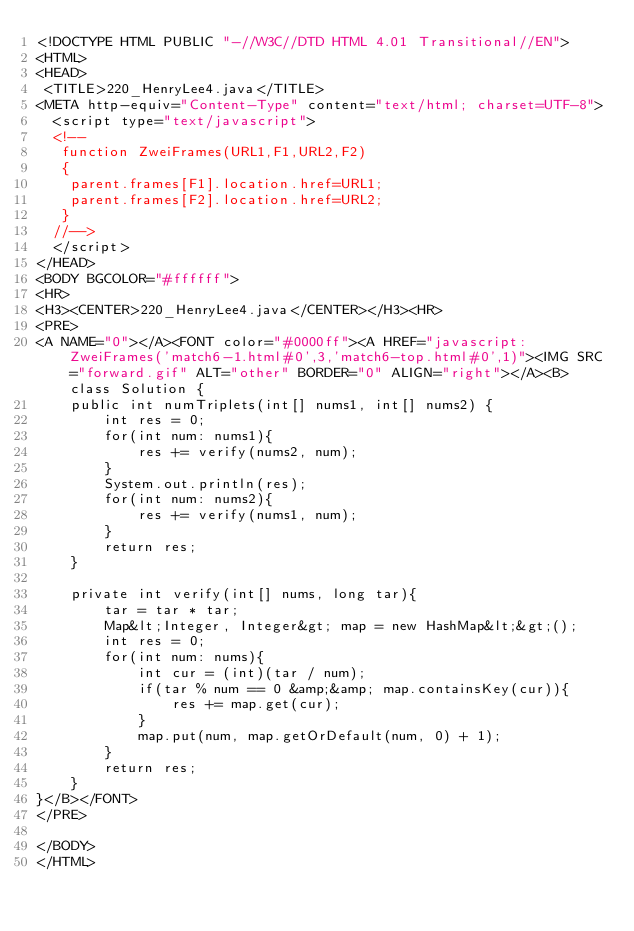Convert code to text. <code><loc_0><loc_0><loc_500><loc_500><_HTML_><!DOCTYPE HTML PUBLIC "-//W3C//DTD HTML 4.01 Transitional//EN">
<HTML>
<HEAD>
 <TITLE>220_HenryLee4.java</TITLE>
<META http-equiv="Content-Type" content="text/html; charset=UTF-8">
  <script type="text/javascript">
  <!--
   function ZweiFrames(URL1,F1,URL2,F2)
   {
    parent.frames[F1].location.href=URL1;
    parent.frames[F2].location.href=URL2;
   }
  //-->
  </script>
</HEAD>
<BODY BGCOLOR="#ffffff">
<HR>
<H3><CENTER>220_HenryLee4.java</CENTER></H3><HR>
<PRE>
<A NAME="0"></A><FONT color="#0000ff"><A HREF="javascript:ZweiFrames('match6-1.html#0',3,'match6-top.html#0',1)"><IMG SRC="forward.gif" ALT="other" BORDER="0" ALIGN="right"></A><B>class Solution {
    public int numTriplets(int[] nums1, int[] nums2) {
        int res = 0;
        for(int num: nums1){
            res += verify(nums2, num);
        }
        System.out.println(res);
        for(int num: nums2){
            res += verify(nums1, num);
        }
        return res;
    }
    
    private int verify(int[] nums, long tar){
        tar = tar * tar;
        Map&lt;Integer, Integer&gt; map = new HashMap&lt;&gt;();
        int res = 0;
        for(int num: nums){
            int cur = (int)(tar / num);
            if(tar % num == 0 &amp;&amp; map.containsKey(cur)){
                res += map.get(cur);
            }
            map.put(num, map.getOrDefault(num, 0) + 1);
        }
        return res;
    }
}</B></FONT>
</PRE>

</BODY>
</HTML>
</code> 